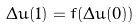<formula> <loc_0><loc_0><loc_500><loc_500>\Delta u ( 1 ) = f ( \Delta u ( 0 ) )</formula> 